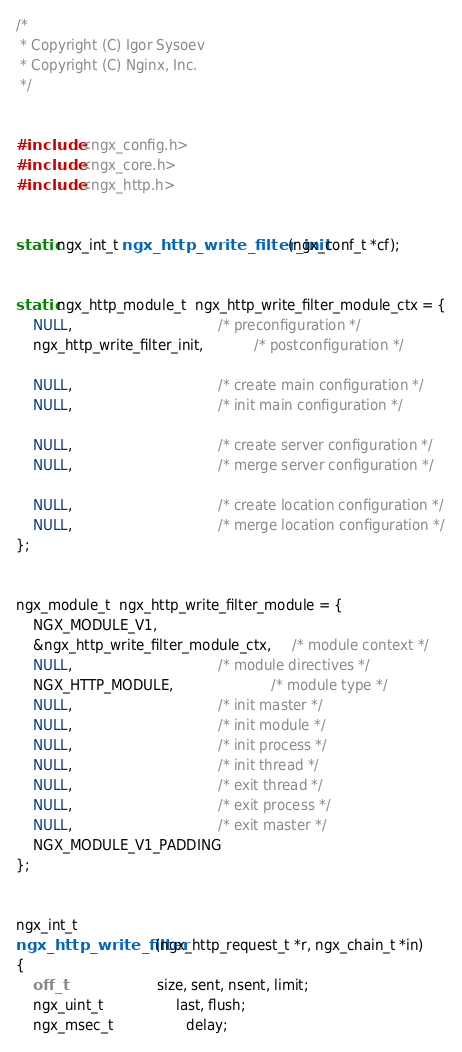Convert code to text. <code><loc_0><loc_0><loc_500><loc_500><_C_>
/*
 * Copyright (C) Igor Sysoev
 * Copyright (C) Nginx, Inc.
 */


#include <ngx_config.h>
#include <ngx_core.h>
#include <ngx_http.h>


static ngx_int_t ngx_http_write_filter_init(ngx_conf_t *cf);


static ngx_http_module_t  ngx_http_write_filter_module_ctx = {
    NULL,                                  /* preconfiguration */
    ngx_http_write_filter_init,            /* postconfiguration */

    NULL,                                  /* create main configuration */
    NULL,                                  /* init main configuration */

    NULL,                                  /* create server configuration */
    NULL,                                  /* merge server configuration */

    NULL,                                  /* create location configuration */
    NULL,                                  /* merge location configuration */
};


ngx_module_t  ngx_http_write_filter_module = {
    NGX_MODULE_V1,
    &ngx_http_write_filter_module_ctx,     /* module context */
    NULL,                                  /* module directives */
    NGX_HTTP_MODULE,                       /* module type */
    NULL,                                  /* init master */
    NULL,                                  /* init module */
    NULL,                                  /* init process */
    NULL,                                  /* init thread */
    NULL,                                  /* exit thread */
    NULL,                                  /* exit process */
    NULL,                                  /* exit master */
    NGX_MODULE_V1_PADDING
};


ngx_int_t
ngx_http_write_filter(ngx_http_request_t *r, ngx_chain_t *in)
{
    off_t                      size, sent, nsent, limit;
    ngx_uint_t                 last, flush;
    ngx_msec_t                 delay;</code> 